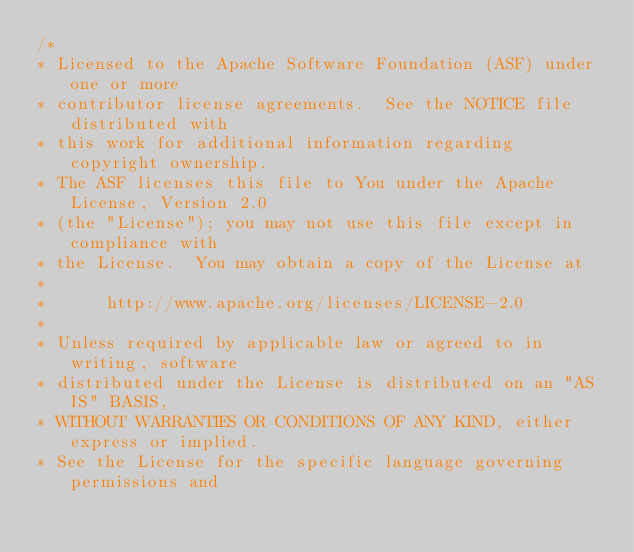Convert code to text. <code><loc_0><loc_0><loc_500><loc_500><_Java_>/*
* Licensed to the Apache Software Foundation (ASF) under one or more
* contributor license agreements.  See the NOTICE file distributed with
* this work for additional information regarding copyright ownership.
* The ASF licenses this file to You under the Apache License, Version 2.0
* (the "License"); you may not use this file except in compliance with
* the License.  You may obtain a copy of the License at
*
*      http://www.apache.org/licenses/LICENSE-2.0
*
* Unless required by applicable law or agreed to in writing, software
* distributed under the License is distributed on an "AS IS" BASIS,
* WITHOUT WARRANTIES OR CONDITIONS OF ANY KIND, either express or implied.
* See the License for the specific language governing permissions and</code> 